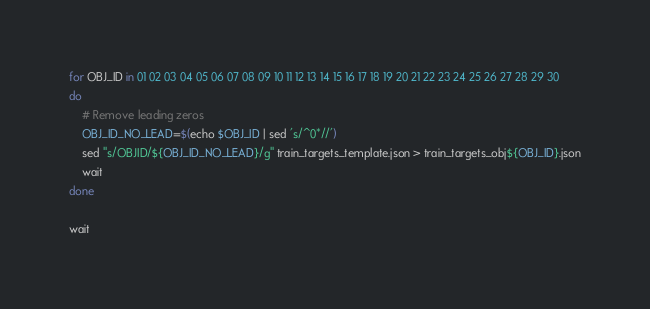Convert code to text. <code><loc_0><loc_0><loc_500><loc_500><_Bash_>for OBJ_ID in 01 02 03 04 05 06 07 08 09 10 11 12 13 14 15 16 17 18 19 20 21 22 23 24 25 26 27 28 29 30
do
    # Remove leading zeros
    OBJ_ID_NO_LEAD=$(echo $OBJ_ID | sed 's/^0*//')
    sed "s/OBJID/${OBJ_ID_NO_LEAD}/g" train_targets_template.json > train_targets_obj${OBJ_ID}.json
    wait
done

wait
</code> 